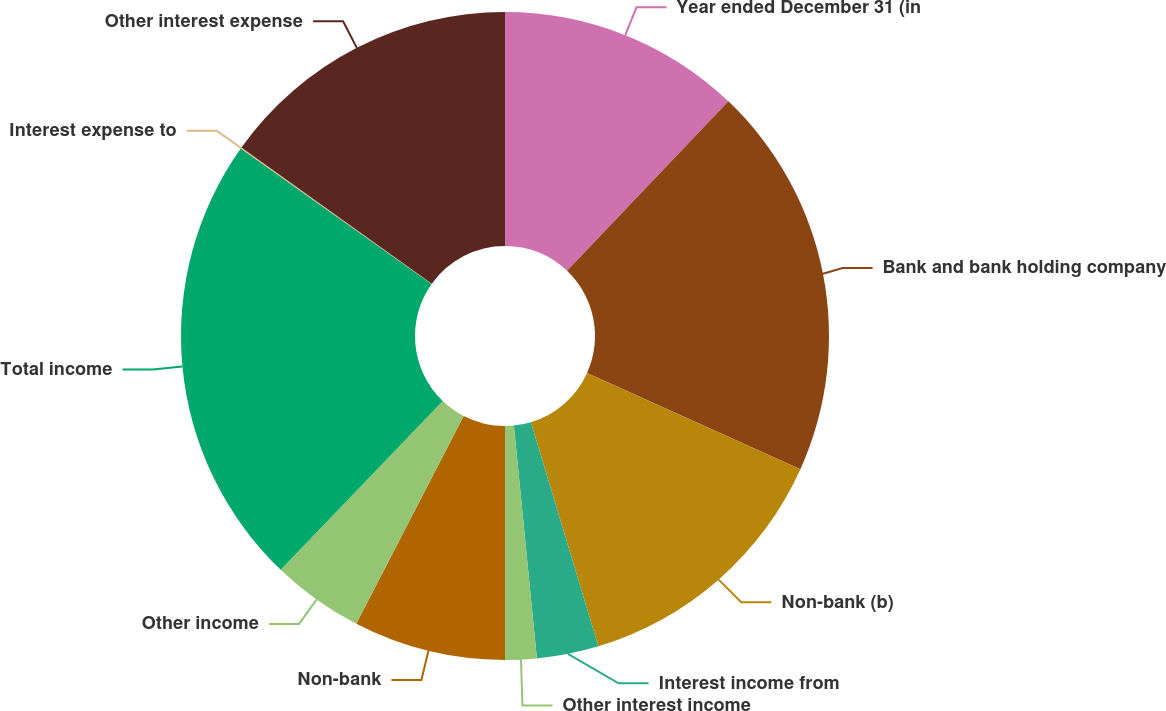Convert chart. <chart><loc_0><loc_0><loc_500><loc_500><pie_chart><fcel>Year ended December 31 (in<fcel>Bank and bank holding company<fcel>Non-bank (b)<fcel>Interest income from<fcel>Other interest income<fcel>Non-bank<fcel>Other income<fcel>Total income<fcel>Interest expense to<fcel>Other interest expense<nl><fcel>12.11%<fcel>19.63%<fcel>13.61%<fcel>3.08%<fcel>1.57%<fcel>7.59%<fcel>4.58%<fcel>22.65%<fcel>0.06%<fcel>15.12%<nl></chart> 